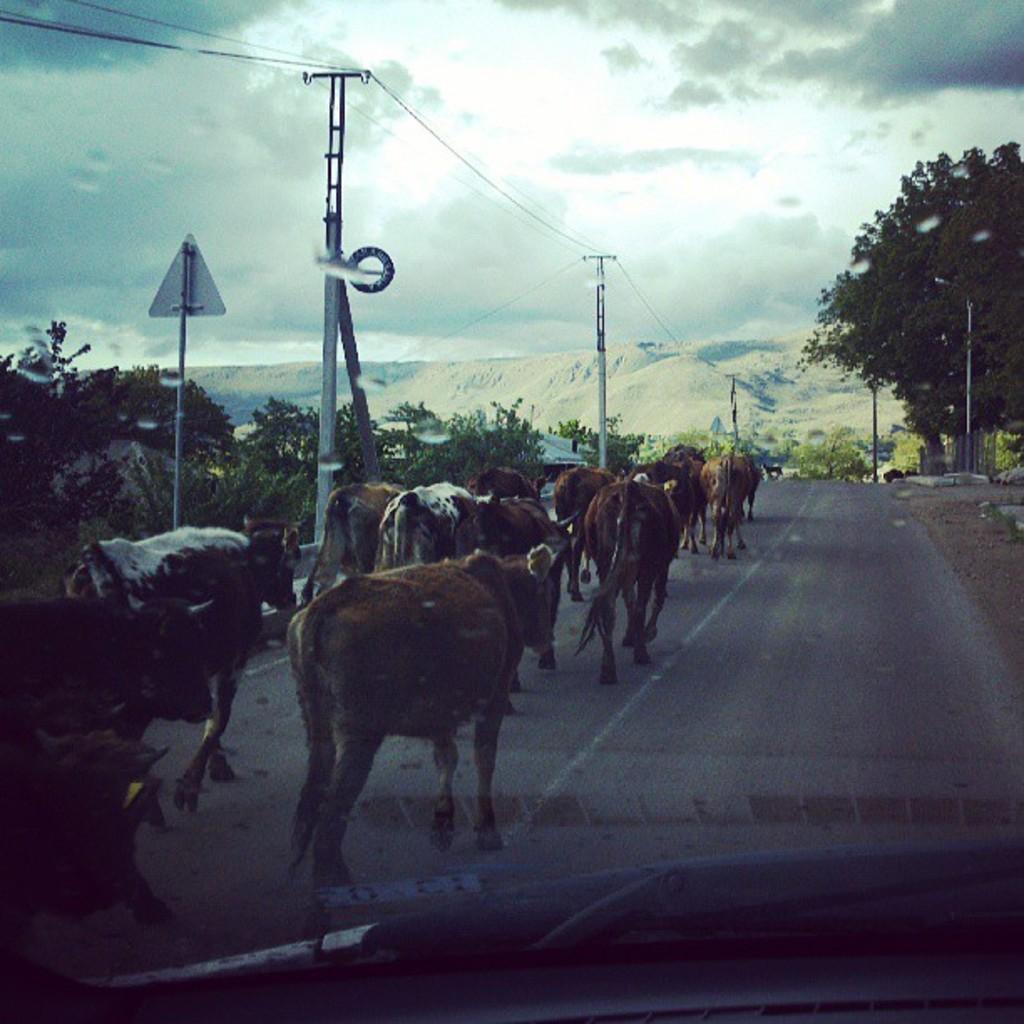Please provide a concise description of this image. The picture is taken from a vehicle. In the foreground on the road there are cattle. On the left there are trees, sign board, current poles and cables. On the right there are trees, poles and plants. In the background there are mountains and trees. Sky is cloudy. 